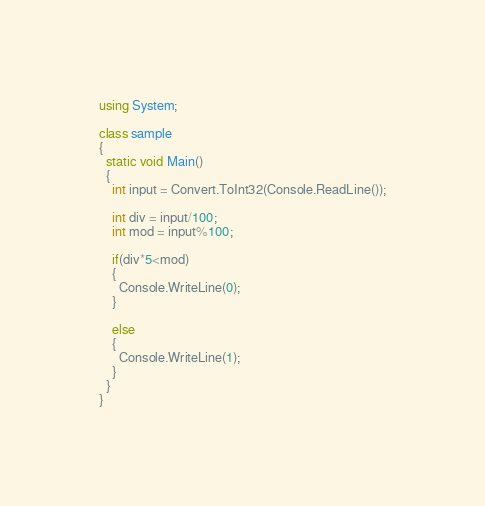<code> <loc_0><loc_0><loc_500><loc_500><_C#_>using System;

class sample
{
  static void Main()
  {
    int input = Convert.ToInt32(Console.ReadLine());
    
    int div = input/100;
    int mod = input%100;
    
    if(div*5<mod)
    {
      Console.WriteLine(0);
    }
    
    else
    {
      Console.WriteLine(1);
    }
  }
}</code> 